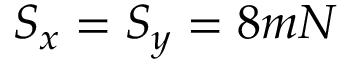Convert formula to latex. <formula><loc_0><loc_0><loc_500><loc_500>S _ { x } = S _ { y } = 8 m N</formula> 